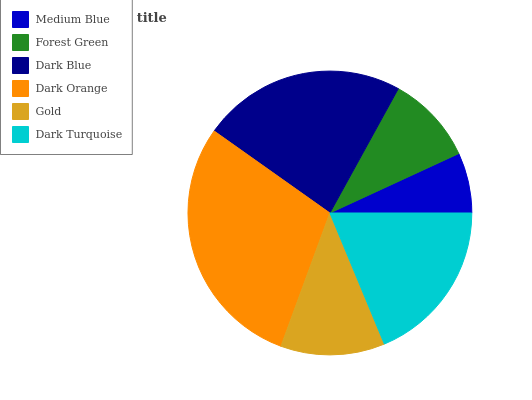Is Medium Blue the minimum?
Answer yes or no. Yes. Is Dark Orange the maximum?
Answer yes or no. Yes. Is Forest Green the minimum?
Answer yes or no. No. Is Forest Green the maximum?
Answer yes or no. No. Is Forest Green greater than Medium Blue?
Answer yes or no. Yes. Is Medium Blue less than Forest Green?
Answer yes or no. Yes. Is Medium Blue greater than Forest Green?
Answer yes or no. No. Is Forest Green less than Medium Blue?
Answer yes or no. No. Is Dark Turquoise the high median?
Answer yes or no. Yes. Is Gold the low median?
Answer yes or no. Yes. Is Dark Blue the high median?
Answer yes or no. No. Is Dark Blue the low median?
Answer yes or no. No. 